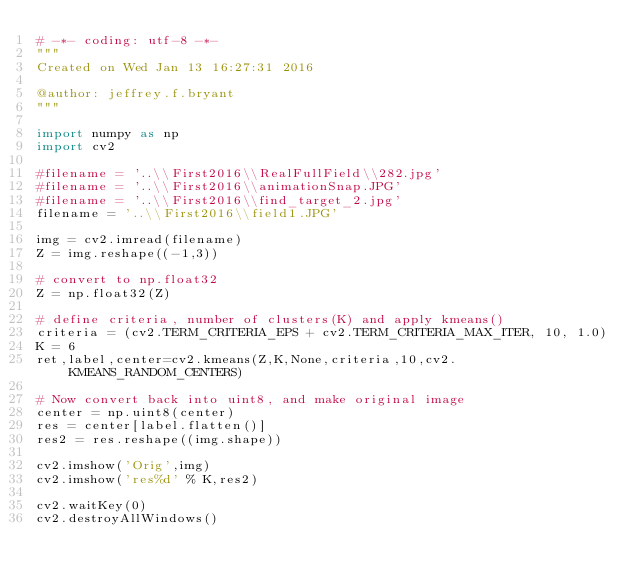<code> <loc_0><loc_0><loc_500><loc_500><_Python_># -*- coding: utf-8 -*-
"""
Created on Wed Jan 13 16:27:31 2016

@author: jeffrey.f.bryant
"""

import numpy as np
import cv2

#filename = '..\\First2016\\RealFullField\\282.jpg'
#filename = '..\\First2016\\animationSnap.JPG'
#filename = '..\\First2016\\find_target_2.jpg'
filename = '..\\First2016\\field1.JPG'

img = cv2.imread(filename)
Z = img.reshape((-1,3))

# convert to np.float32
Z = np.float32(Z)

# define criteria, number of clusters(K) and apply kmeans()
criteria = (cv2.TERM_CRITERIA_EPS + cv2.TERM_CRITERIA_MAX_ITER, 10, 1.0)
K = 6
ret,label,center=cv2.kmeans(Z,K,None,criteria,10,cv2.KMEANS_RANDOM_CENTERS)

# Now convert back into uint8, and make original image
center = np.uint8(center)
res = center[label.flatten()]
res2 = res.reshape((img.shape))

cv2.imshow('Orig',img)
cv2.imshow('res%d' % K,res2)

cv2.waitKey(0)
cv2.destroyAllWindows()</code> 